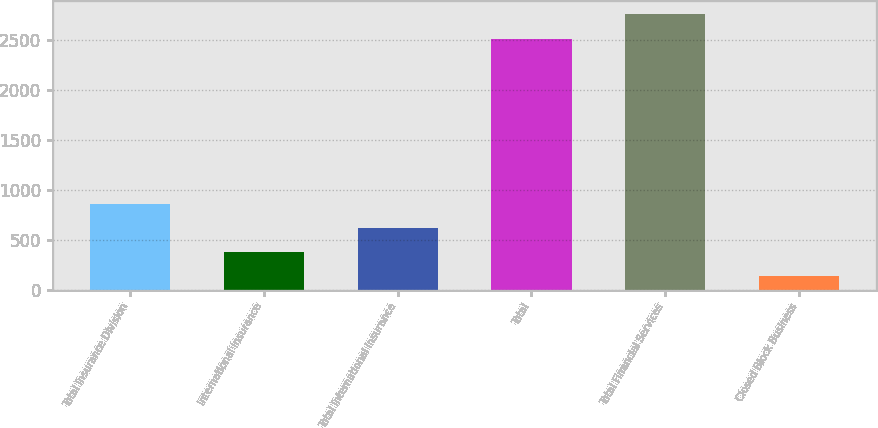<chart> <loc_0><loc_0><loc_500><loc_500><bar_chart><fcel>Total Insurance Division<fcel>International Insurance<fcel>Total International Insurance<fcel>Total<fcel>Total Financial Services<fcel>Closed Block Business<nl><fcel>864.5<fcel>379.5<fcel>622<fcel>2516<fcel>2758.5<fcel>137<nl></chart> 